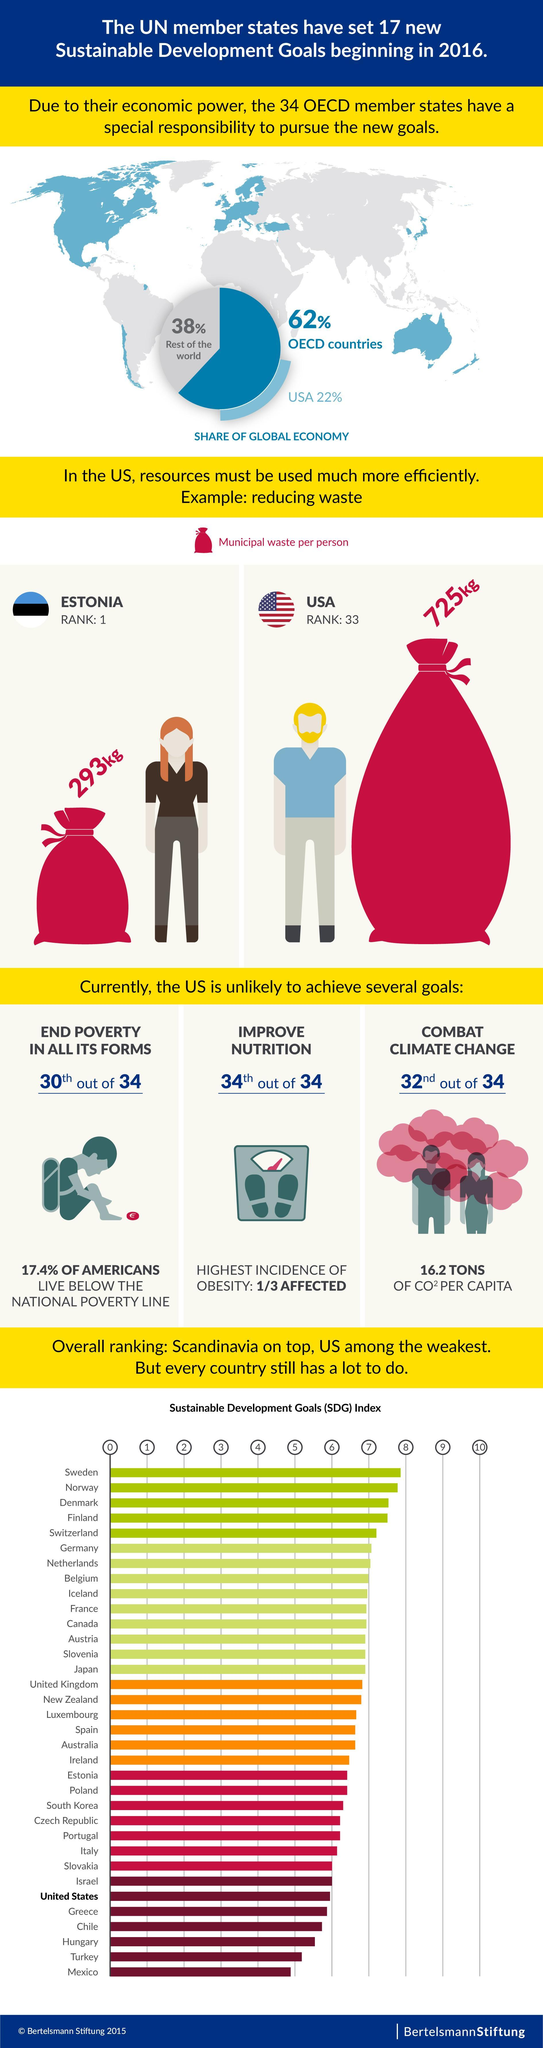What is the percentage share of USA in the global economy?
Answer the question with a short phrase. 22% How much municipal waste is generated per person in the U.S.? 725 kg What is the percentage share of OECD countries in the global economy? 62% What percentage of Americans live above the national poverty line? 82.6% How much municipal waste is generated per person in the Estonia? 293 kg 